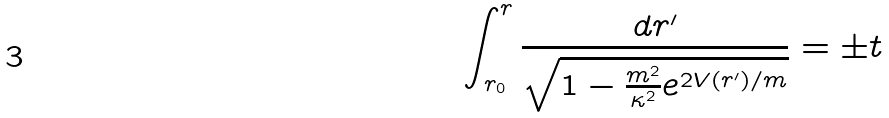Convert formula to latex. <formula><loc_0><loc_0><loc_500><loc_500>\int _ { r _ { 0 } } ^ { r } \frac { d r ^ { \prime } } { \sqrt { 1 - \frac { m ^ { 2 } } { \kappa ^ { 2 } } e ^ { 2 V ( r ^ { \prime } ) / m } } } = \pm t</formula> 